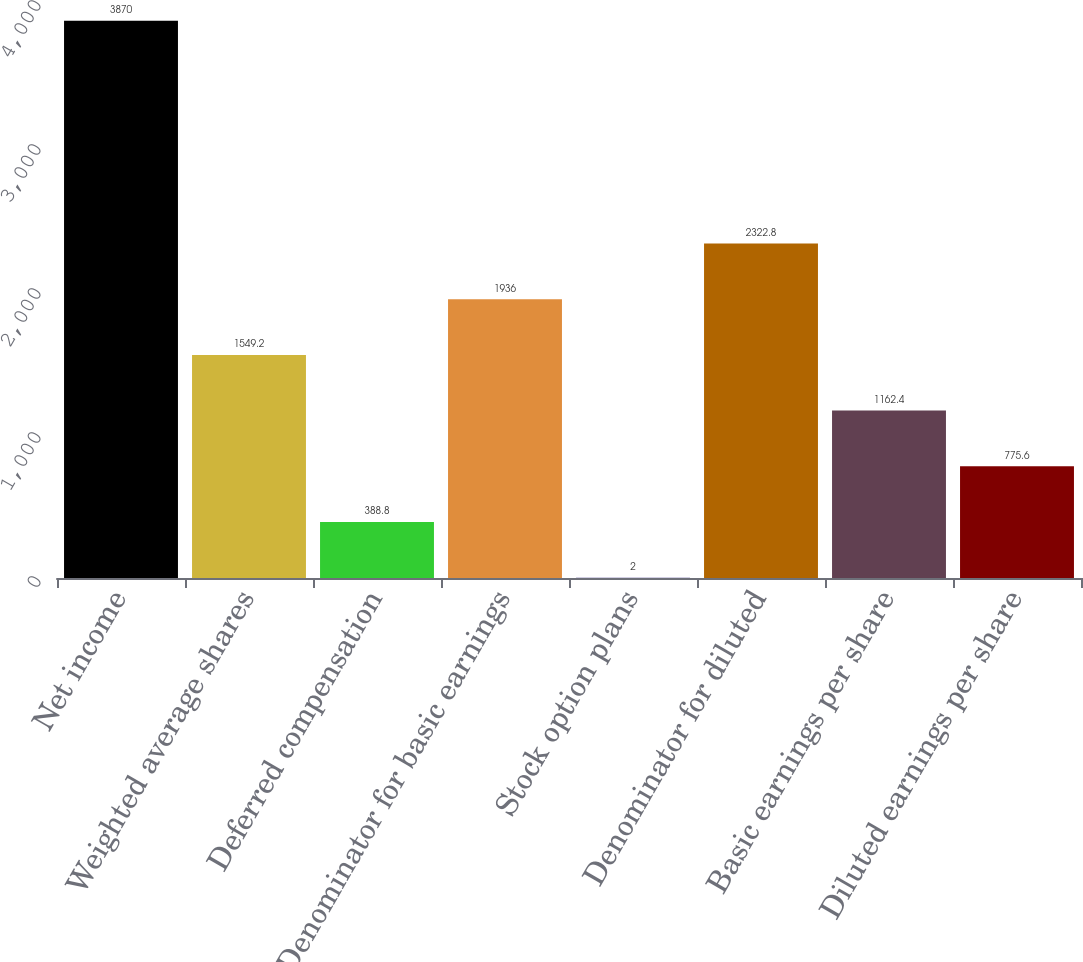Convert chart to OTSL. <chart><loc_0><loc_0><loc_500><loc_500><bar_chart><fcel>Net income<fcel>Weighted average shares<fcel>Deferred compensation<fcel>Denominator for basic earnings<fcel>Stock option plans<fcel>Denominator for diluted<fcel>Basic earnings per share<fcel>Diluted earnings per share<nl><fcel>3870<fcel>1549.2<fcel>388.8<fcel>1936<fcel>2<fcel>2322.8<fcel>1162.4<fcel>775.6<nl></chart> 